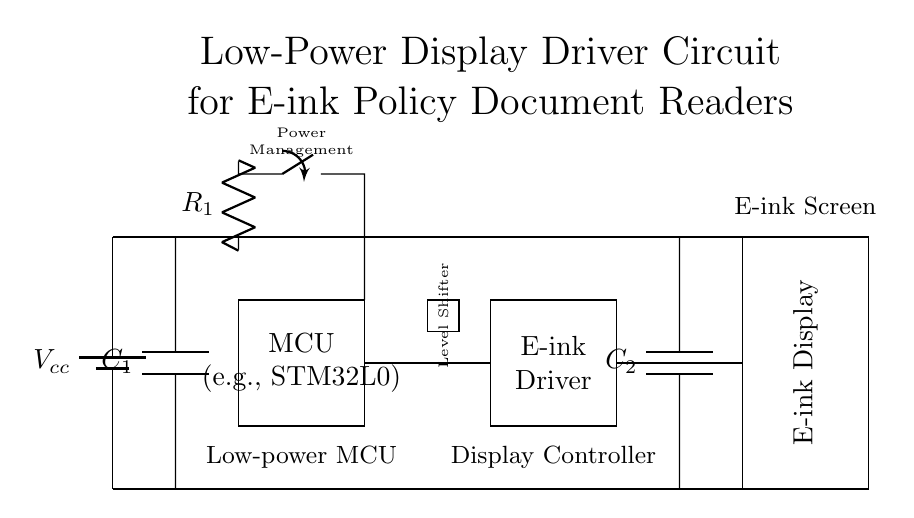What is the main component supplying power in this circuit? The circuit has a battery shown as a power source at the top left, indicating it is the main component providing power.
Answer: Battery What type of microcontroller is used in this circuit? The microcontroller is labeled as "MCU" with the example "STM32L0" indicated inside the rectangle, which specifies the type used.
Answer: STM32L0 What is the purpose of the level shifter in this circuit? The level shifter is used to convert signal voltage levels between components, which is essential when interfacing different voltage logic.
Answer: Voltage conversion Which components are connected to the decoupling capacitors? The first capacitor labeled C1 is connected to the power supply and the microcontroller, while the second capacitor labeled C2 is connected to the e-ink driver and display.
Answer: C1 and C2 How many distinct functional blocks are present in the circuit? The circuit diagram showcases four functional blocks: Power supply, Microcontroller, E-ink Driver, and E-ink Display. Counting these blocks provides the total.
Answer: Four What is the function of the resistor labeled R1? R1 is part of the power management section, functioning as a current limiting element for the microcontroller, helping to ensure proper operation without overcurrent.
Answer: Current limiting What is the role of the e-ink driver in this circuit? The e-ink driver converts signals from the microcontroller into appropriate data and control signals for the e-ink display, making it essential for communication between these components.
Answer: Signal conversion 